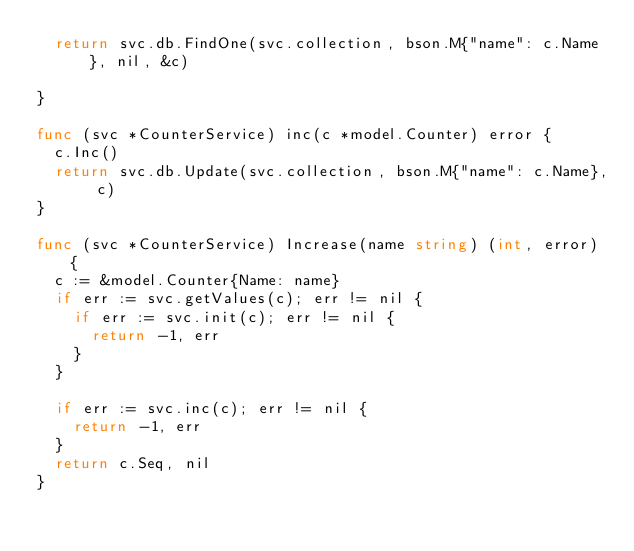<code> <loc_0><loc_0><loc_500><loc_500><_Go_>	return svc.db.FindOne(svc.collection, bson.M{"name": c.Name}, nil, &c)

}

func (svc *CounterService) inc(c *model.Counter) error {
	c.Inc()
	return svc.db.Update(svc.collection, bson.M{"name": c.Name}, c)
}

func (svc *CounterService) Increase(name string) (int, error) {
	c := &model.Counter{Name: name}
	if err := svc.getValues(c); err != nil {
		if err := svc.init(c); err != nil {
			return -1, err
		}
	}

	if err := svc.inc(c); err != nil {
		return -1, err
	}
	return c.Seq, nil
}
</code> 